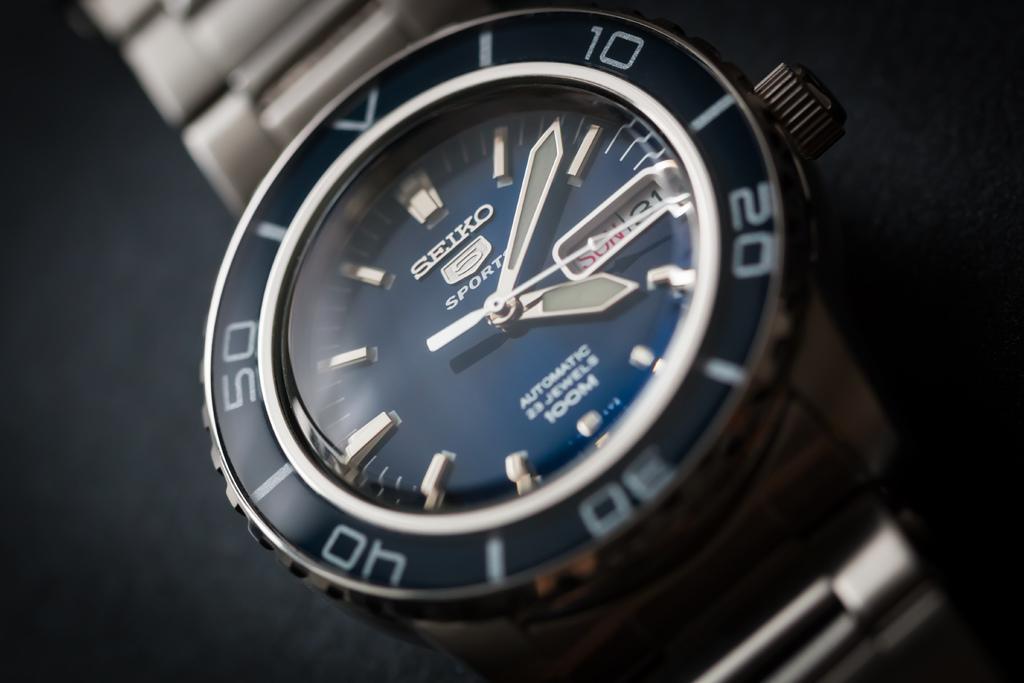In one or two sentences, can you explain what this image depicts? In this picture we can see a wrist watch in the front, there is a blurry background. 